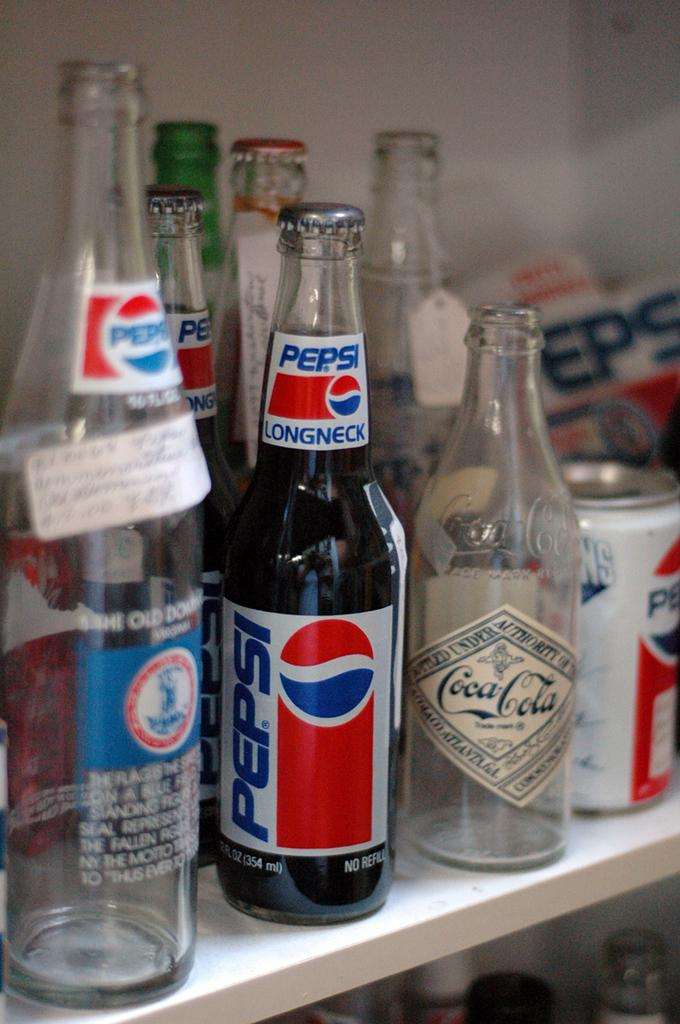What type of containers are present in the image? There are bottles and a can in the image. What can be found on the bottles and/or can? There are words written on the bottles and/or can. How does the daughter feel about the cook in the image? There is no daughter or cook present in the image; it only features bottles and a can with words written on them. 